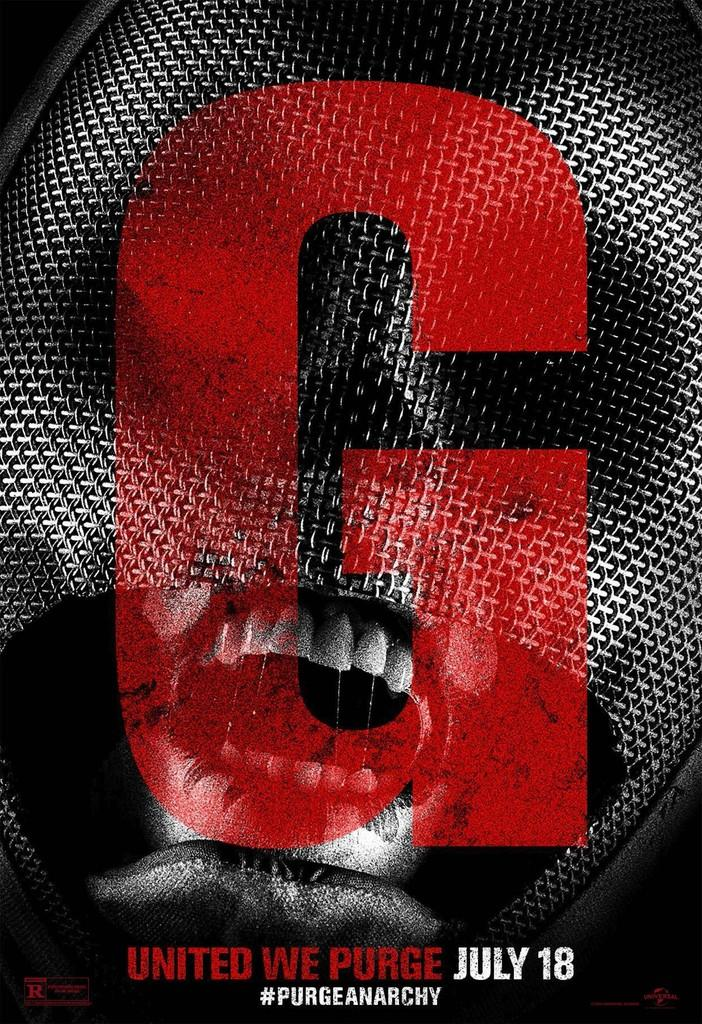<image>
Render a clear and concise summary of the photo. a G logo for some kind of cinema film coming out in july i think its related to purge movie 